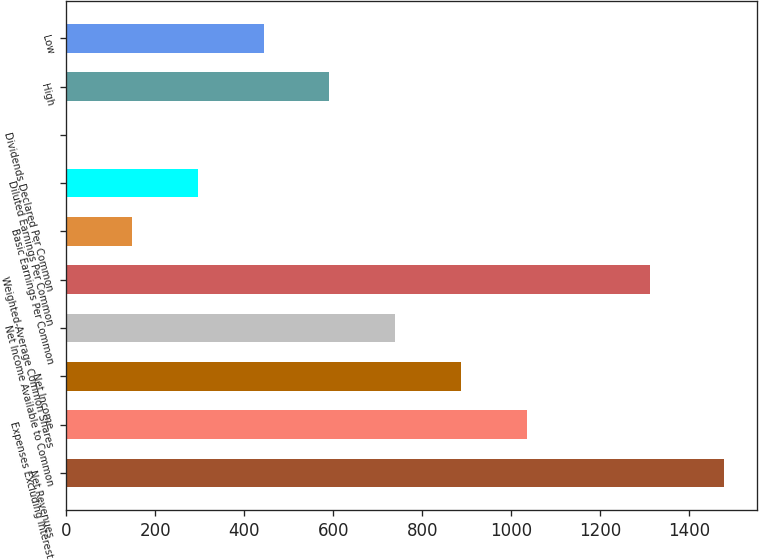Convert chart to OTSL. <chart><loc_0><loc_0><loc_500><loc_500><bar_chart><fcel>Net Revenues<fcel>Expenses Excluding Interest<fcel>Net Income<fcel>Net Income Available to Common<fcel>Weighted-Average Common Shares<fcel>Basic Earnings Per Common<fcel>Diluted Earnings Per Common<fcel>Dividends Declared Per Common<fcel>High<fcel>Low<nl><fcel>1478<fcel>1034.59<fcel>886.8<fcel>739.01<fcel>1313<fcel>147.85<fcel>295.64<fcel>0.06<fcel>591.22<fcel>443.43<nl></chart> 